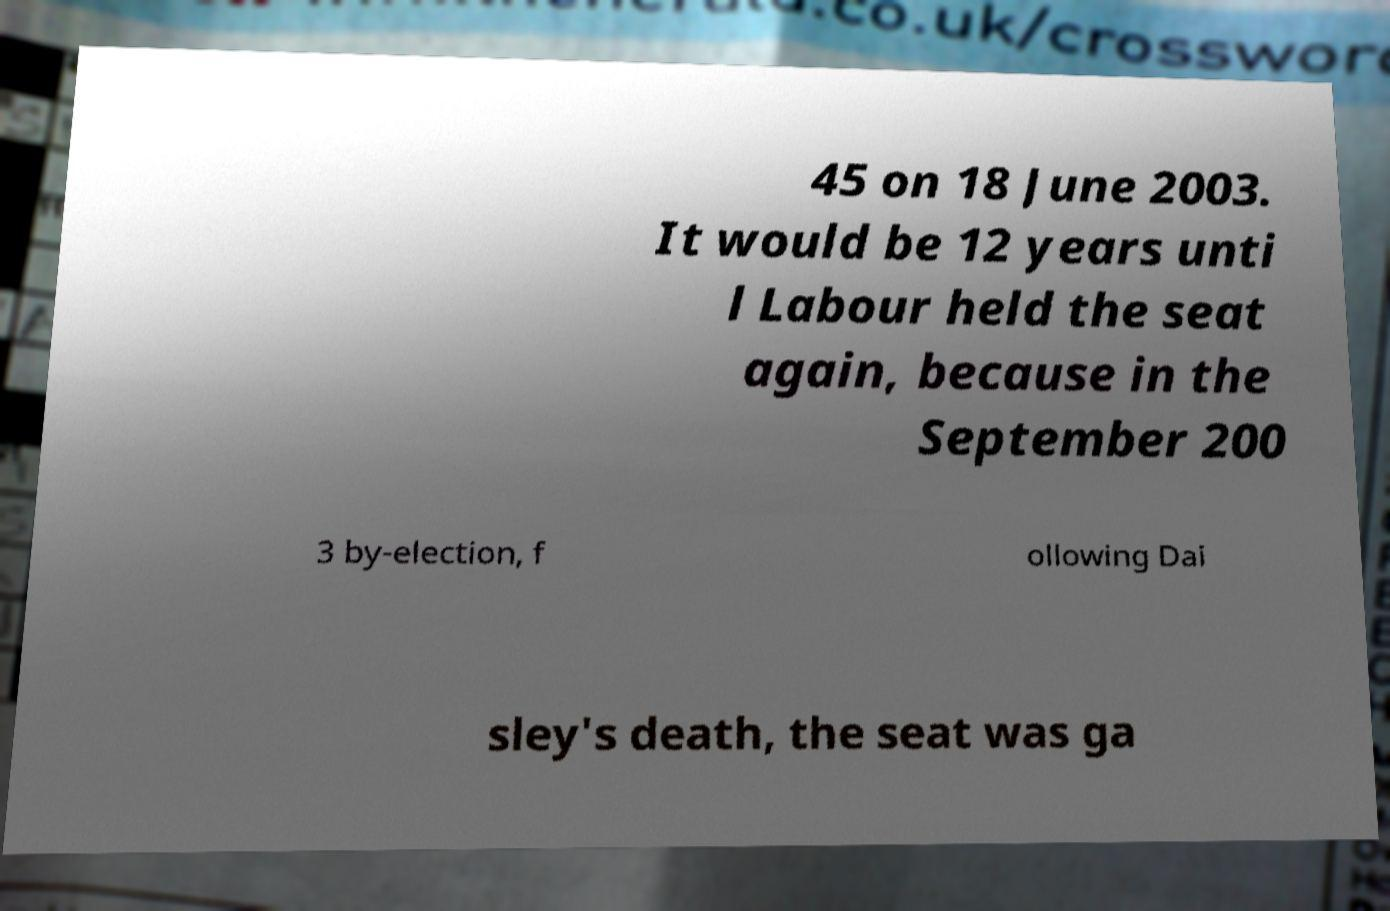Please identify and transcribe the text found in this image. 45 on 18 June 2003. It would be 12 years unti l Labour held the seat again, because in the September 200 3 by-election, f ollowing Dai sley's death, the seat was ga 